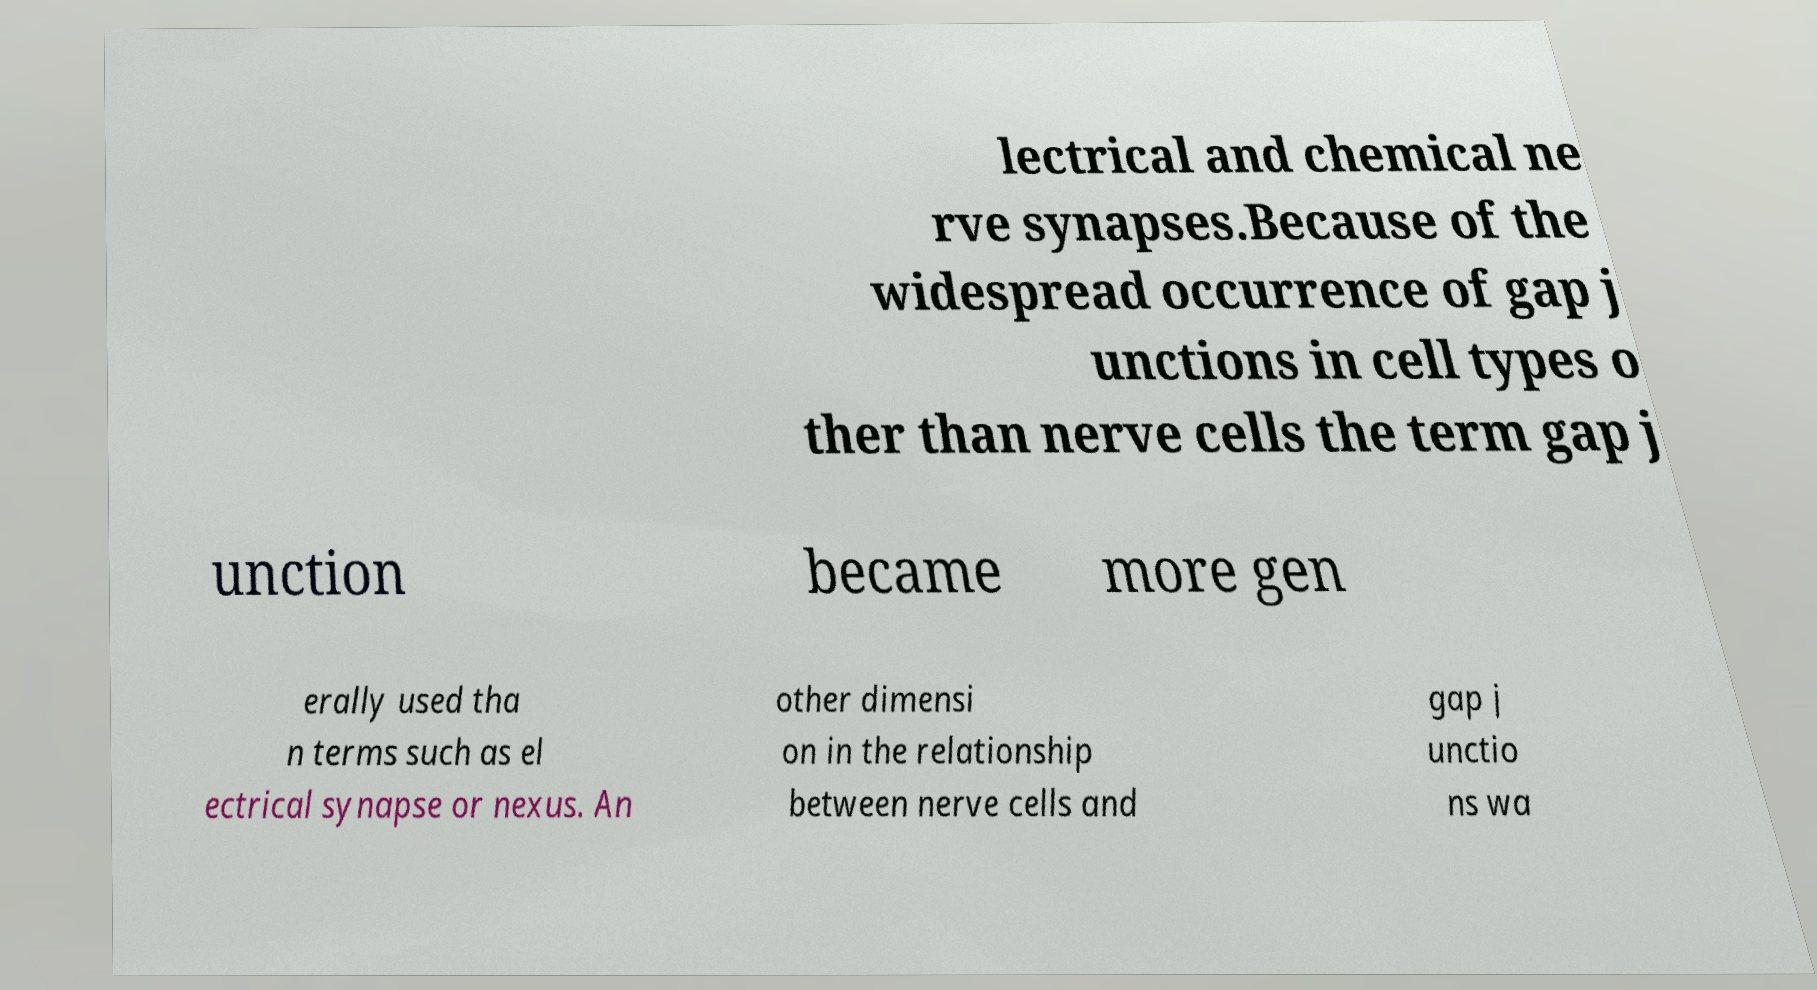Could you assist in decoding the text presented in this image and type it out clearly? lectrical and chemical ne rve synapses.Because of the widespread occurrence of gap j unctions in cell types o ther than nerve cells the term gap j unction became more gen erally used tha n terms such as el ectrical synapse or nexus. An other dimensi on in the relationship between nerve cells and gap j unctio ns wa 